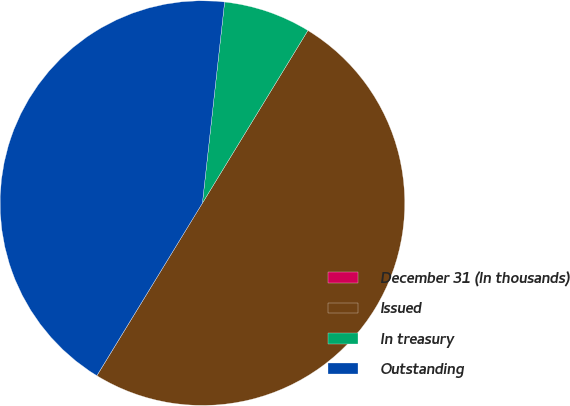Convert chart. <chart><loc_0><loc_0><loc_500><loc_500><pie_chart><fcel>December 31 (In thousands)<fcel>Issued<fcel>In treasury<fcel>Outstanding<nl><fcel>0.01%<fcel>50.0%<fcel>6.98%<fcel>43.01%<nl></chart> 